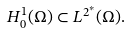Convert formula to latex. <formula><loc_0><loc_0><loc_500><loc_500>H ^ { 1 } _ { 0 } ( \Omega ) \subset L ^ { 2 ^ { * } } ( \Omega ) .</formula> 